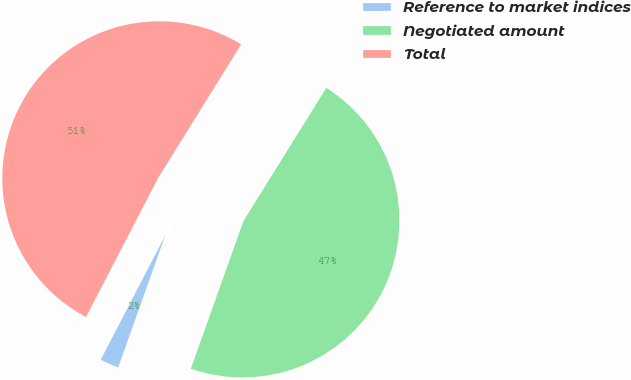Convert chart. <chart><loc_0><loc_0><loc_500><loc_500><pie_chart><fcel>Reference to market indices<fcel>Negotiated amount<fcel>Total<nl><fcel>2.16%<fcel>46.59%<fcel>51.25%<nl></chart> 